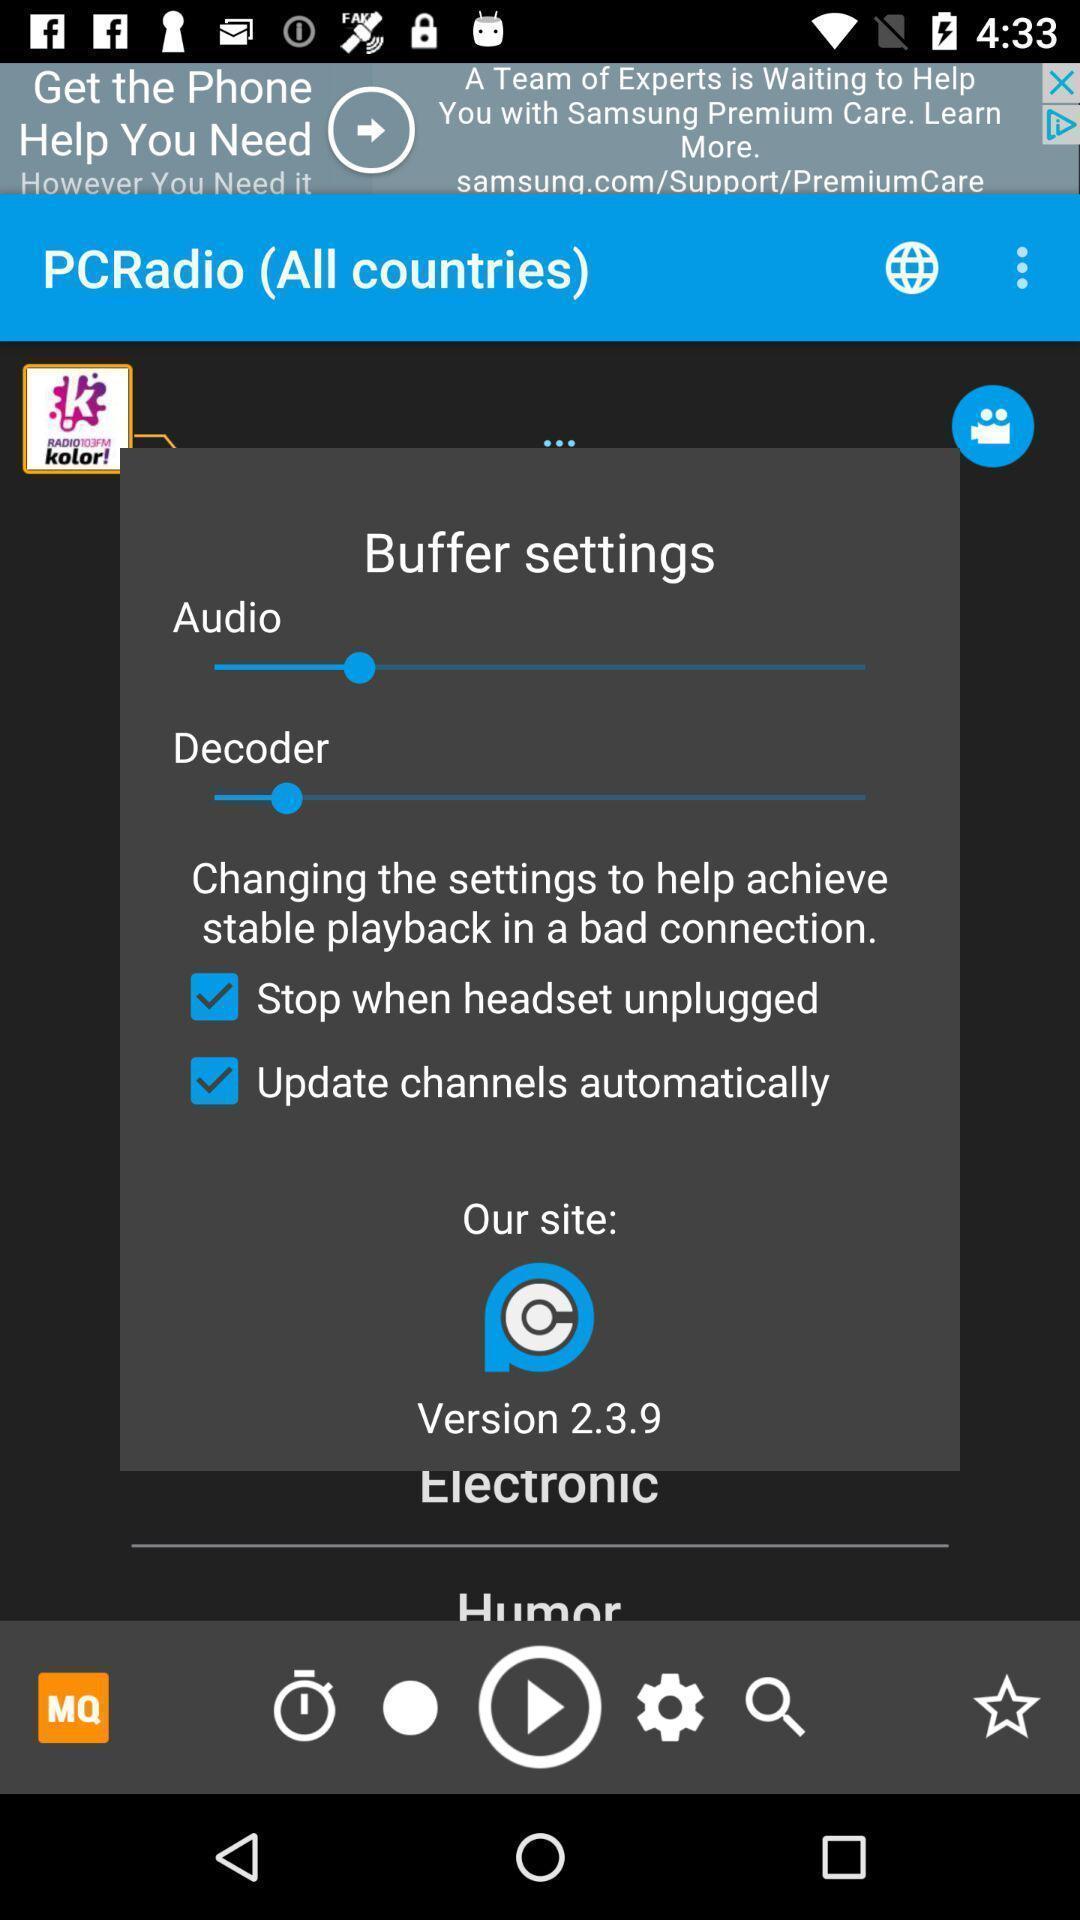Describe the key features of this screenshot. Pop-up showing audio settings. 